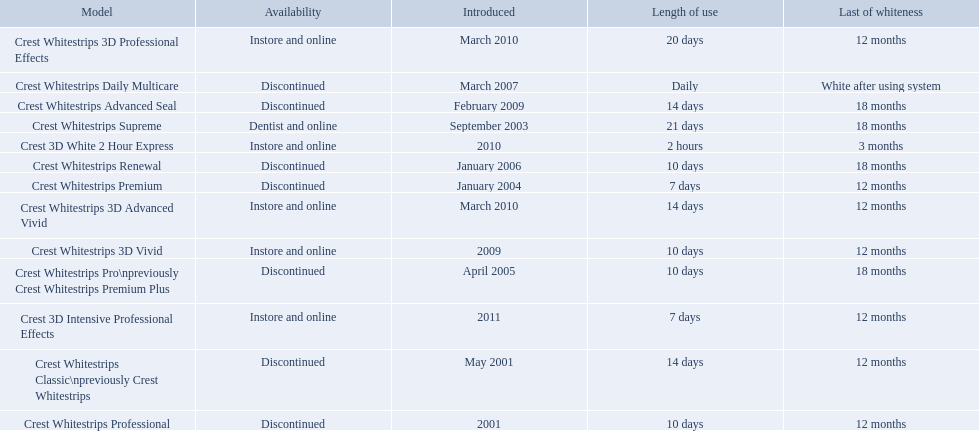What types of crest whitestrips have been released? Crest Whitestrips Classic\npreviously Crest Whitestrips, Crest Whitestrips Professional, Crest Whitestrips Supreme, Crest Whitestrips Premium, Crest Whitestrips Pro\npreviously Crest Whitestrips Premium Plus, Crest Whitestrips Renewal, Crest Whitestrips Daily Multicare, Crest Whitestrips Advanced Seal, Crest Whitestrips 3D Vivid, Crest Whitestrips 3D Advanced Vivid, Crest Whitestrips 3D Professional Effects, Crest 3D White 2 Hour Express, Crest 3D Intensive Professional Effects. What was the length of use for each type? 14 days, 10 days, 21 days, 7 days, 10 days, 10 days, Daily, 14 days, 10 days, 14 days, 20 days, 2 hours, 7 days. And how long did each last? 12 months, 12 months, 18 months, 12 months, 18 months, 18 months, White after using system, 18 months, 12 months, 12 months, 12 months, 3 months, 12 months. Of those models, which lasted the longest with the longest length of use? Crest Whitestrips Supreme. 